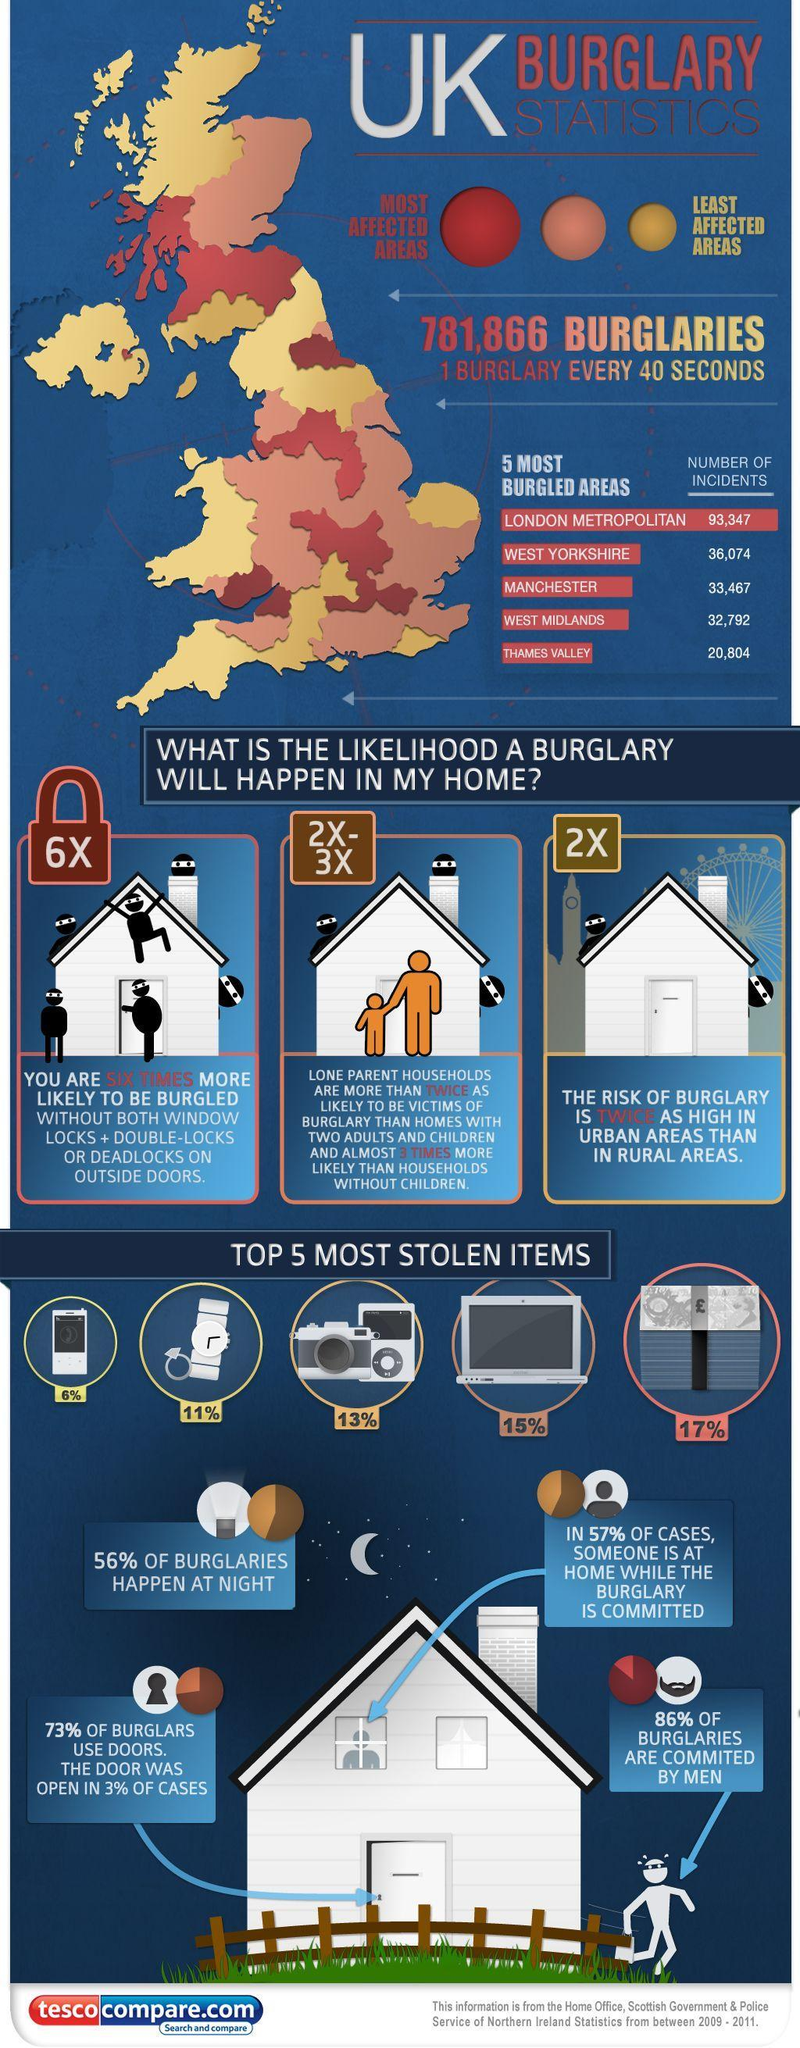What percentage of burglaries are not committed by men?
Answer the question with a short phrase. 14% Which color is used to represent the least affected areas of burglary -orange, red, or yellow? yellow What percentage of burglaries not happen at night? 44% What percentage of burglars did not use doors? 27% Which color is used to represent the most affected areas of burglary  -orange, red, or yellow? red 